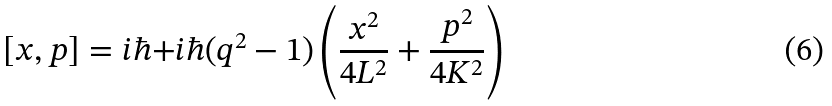<formula> <loc_0><loc_0><loc_500><loc_500>[ x , p ] = i \hbar { + } i \hbar { ( } q ^ { 2 } - 1 ) \left ( \frac { x ^ { 2 } } { 4 L ^ { 2 } } + \frac { p ^ { 2 } } { 4 K ^ { 2 } } \right )</formula> 